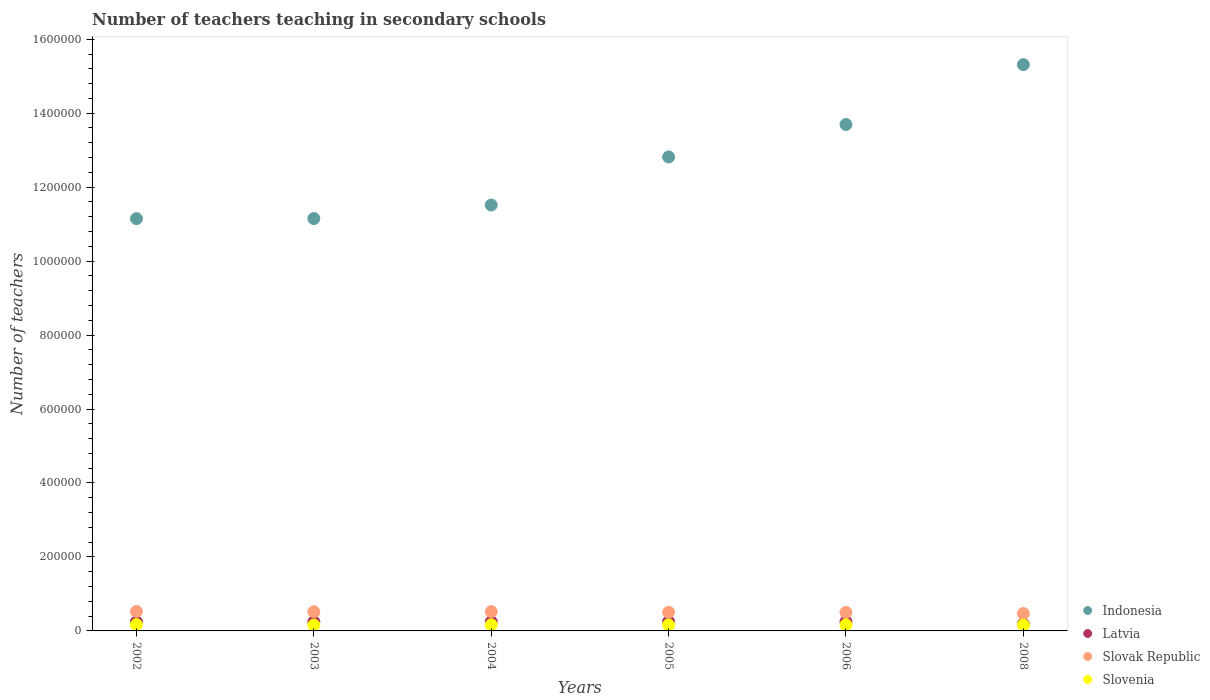How many different coloured dotlines are there?
Make the answer very short. 4. What is the number of teachers teaching in secondary schools in Slovak Republic in 2002?
Ensure brevity in your answer.  5.26e+04. Across all years, what is the maximum number of teachers teaching in secondary schools in Indonesia?
Offer a terse response. 1.53e+06. Across all years, what is the minimum number of teachers teaching in secondary schools in Slovak Republic?
Offer a very short reply. 4.70e+04. In which year was the number of teachers teaching in secondary schools in Slovenia maximum?
Your response must be concise. 2002. In which year was the number of teachers teaching in secondary schools in Slovak Republic minimum?
Provide a succinct answer. 2008. What is the total number of teachers teaching in secondary schools in Slovak Republic in the graph?
Ensure brevity in your answer.  3.04e+05. What is the difference between the number of teachers teaching in secondary schools in Indonesia in 2004 and that in 2005?
Offer a terse response. -1.30e+05. What is the difference between the number of teachers teaching in secondary schools in Indonesia in 2004 and the number of teachers teaching in secondary schools in Slovak Republic in 2003?
Offer a terse response. 1.10e+06. What is the average number of teachers teaching in secondary schools in Slovenia per year?
Offer a terse response. 1.63e+04. In the year 2008, what is the difference between the number of teachers teaching in secondary schools in Slovenia and number of teachers teaching in secondary schools in Indonesia?
Ensure brevity in your answer.  -1.52e+06. What is the ratio of the number of teachers teaching in secondary schools in Slovak Republic in 2005 to that in 2006?
Make the answer very short. 1.01. Is the number of teachers teaching in secondary schools in Slovenia in 2002 less than that in 2006?
Your response must be concise. No. Is the difference between the number of teachers teaching in secondary schools in Slovenia in 2002 and 2004 greater than the difference between the number of teachers teaching in secondary schools in Indonesia in 2002 and 2004?
Your answer should be very brief. Yes. What is the difference between the highest and the second highest number of teachers teaching in secondary schools in Indonesia?
Your answer should be compact. 1.62e+05. What is the difference between the highest and the lowest number of teachers teaching in secondary schools in Slovak Republic?
Offer a very short reply. 5637. In how many years, is the number of teachers teaching in secondary schools in Indonesia greater than the average number of teachers teaching in secondary schools in Indonesia taken over all years?
Keep it short and to the point. 3. Is the sum of the number of teachers teaching in secondary schools in Indonesia in 2005 and 2008 greater than the maximum number of teachers teaching in secondary schools in Slovenia across all years?
Your response must be concise. Yes. Is it the case that in every year, the sum of the number of teachers teaching in secondary schools in Indonesia and number of teachers teaching in secondary schools in Slovak Republic  is greater than the sum of number of teachers teaching in secondary schools in Latvia and number of teachers teaching in secondary schools in Slovenia?
Make the answer very short. No. Is the number of teachers teaching in secondary schools in Slovenia strictly less than the number of teachers teaching in secondary schools in Slovak Republic over the years?
Your answer should be very brief. Yes. How many dotlines are there?
Your answer should be compact. 4. Are the values on the major ticks of Y-axis written in scientific E-notation?
Ensure brevity in your answer.  No. How many legend labels are there?
Your answer should be very brief. 4. What is the title of the graph?
Your response must be concise. Number of teachers teaching in secondary schools. Does "Monaco" appear as one of the legend labels in the graph?
Offer a very short reply. No. What is the label or title of the Y-axis?
Provide a succinct answer. Number of teachers. What is the Number of teachers of Indonesia in 2002?
Keep it short and to the point. 1.11e+06. What is the Number of teachers in Latvia in 2002?
Make the answer very short. 2.45e+04. What is the Number of teachers in Slovak Republic in 2002?
Make the answer very short. 5.26e+04. What is the Number of teachers in Slovenia in 2002?
Your answer should be compact. 1.69e+04. What is the Number of teachers of Indonesia in 2003?
Your answer should be compact. 1.12e+06. What is the Number of teachers of Latvia in 2003?
Make the answer very short. 2.48e+04. What is the Number of teachers in Slovak Republic in 2003?
Ensure brevity in your answer.  5.18e+04. What is the Number of teachers of Slovenia in 2003?
Provide a short and direct response. 1.58e+04. What is the Number of teachers in Indonesia in 2004?
Offer a very short reply. 1.15e+06. What is the Number of teachers of Latvia in 2004?
Provide a short and direct response. 2.50e+04. What is the Number of teachers in Slovak Republic in 2004?
Your answer should be very brief. 5.22e+04. What is the Number of teachers of Slovenia in 2004?
Provide a succinct answer. 1.65e+04. What is the Number of teachers in Indonesia in 2005?
Ensure brevity in your answer.  1.28e+06. What is the Number of teachers in Latvia in 2005?
Make the answer very short. 2.51e+04. What is the Number of teachers in Slovak Republic in 2005?
Give a very brief answer. 5.05e+04. What is the Number of teachers in Slovenia in 2005?
Provide a short and direct response. 1.62e+04. What is the Number of teachers in Indonesia in 2006?
Make the answer very short. 1.37e+06. What is the Number of teachers in Latvia in 2006?
Offer a terse response. 2.52e+04. What is the Number of teachers in Slovak Republic in 2006?
Keep it short and to the point. 4.99e+04. What is the Number of teachers in Slovenia in 2006?
Offer a terse response. 1.64e+04. What is the Number of teachers of Indonesia in 2008?
Your answer should be compact. 1.53e+06. What is the Number of teachers of Latvia in 2008?
Offer a very short reply. 1.86e+04. What is the Number of teachers of Slovak Republic in 2008?
Give a very brief answer. 4.70e+04. What is the Number of teachers of Slovenia in 2008?
Provide a succinct answer. 1.58e+04. Across all years, what is the maximum Number of teachers in Indonesia?
Your answer should be compact. 1.53e+06. Across all years, what is the maximum Number of teachers of Latvia?
Give a very brief answer. 2.52e+04. Across all years, what is the maximum Number of teachers in Slovak Republic?
Offer a very short reply. 5.26e+04. Across all years, what is the maximum Number of teachers of Slovenia?
Offer a very short reply. 1.69e+04. Across all years, what is the minimum Number of teachers in Indonesia?
Your response must be concise. 1.11e+06. Across all years, what is the minimum Number of teachers in Latvia?
Offer a very short reply. 1.86e+04. Across all years, what is the minimum Number of teachers in Slovak Republic?
Provide a short and direct response. 4.70e+04. Across all years, what is the minimum Number of teachers of Slovenia?
Give a very brief answer. 1.58e+04. What is the total Number of teachers in Indonesia in the graph?
Ensure brevity in your answer.  7.56e+06. What is the total Number of teachers in Latvia in the graph?
Offer a very short reply. 1.43e+05. What is the total Number of teachers of Slovak Republic in the graph?
Ensure brevity in your answer.  3.04e+05. What is the total Number of teachers of Slovenia in the graph?
Your answer should be very brief. 9.76e+04. What is the difference between the Number of teachers in Indonesia in 2002 and that in 2003?
Your answer should be very brief. -300. What is the difference between the Number of teachers of Latvia in 2002 and that in 2003?
Provide a short and direct response. -275. What is the difference between the Number of teachers of Slovak Republic in 2002 and that in 2003?
Your answer should be very brief. 809. What is the difference between the Number of teachers of Slovenia in 2002 and that in 2003?
Offer a very short reply. 1104. What is the difference between the Number of teachers of Indonesia in 2002 and that in 2004?
Offer a very short reply. -3.68e+04. What is the difference between the Number of teachers of Latvia in 2002 and that in 2004?
Provide a short and direct response. -497. What is the difference between the Number of teachers in Slovak Republic in 2002 and that in 2004?
Offer a terse response. 434. What is the difference between the Number of teachers in Slovenia in 2002 and that in 2004?
Your response must be concise. 493. What is the difference between the Number of teachers of Indonesia in 2002 and that in 2005?
Make the answer very short. -1.67e+05. What is the difference between the Number of teachers of Latvia in 2002 and that in 2005?
Make the answer very short. -632. What is the difference between the Number of teachers in Slovak Republic in 2002 and that in 2005?
Keep it short and to the point. 2100. What is the difference between the Number of teachers of Slovenia in 2002 and that in 2005?
Offer a terse response. 776. What is the difference between the Number of teachers in Indonesia in 2002 and that in 2006?
Your response must be concise. -2.55e+05. What is the difference between the Number of teachers in Latvia in 2002 and that in 2006?
Your answer should be very brief. -710. What is the difference between the Number of teachers of Slovak Republic in 2002 and that in 2006?
Provide a short and direct response. 2730. What is the difference between the Number of teachers in Slovenia in 2002 and that in 2006?
Your answer should be compact. 544. What is the difference between the Number of teachers in Indonesia in 2002 and that in 2008?
Make the answer very short. -4.17e+05. What is the difference between the Number of teachers of Latvia in 2002 and that in 2008?
Your answer should be compact. 5917. What is the difference between the Number of teachers of Slovak Republic in 2002 and that in 2008?
Give a very brief answer. 5637. What is the difference between the Number of teachers in Slovenia in 2002 and that in 2008?
Offer a terse response. 1159. What is the difference between the Number of teachers of Indonesia in 2003 and that in 2004?
Keep it short and to the point. -3.65e+04. What is the difference between the Number of teachers in Latvia in 2003 and that in 2004?
Give a very brief answer. -222. What is the difference between the Number of teachers in Slovak Republic in 2003 and that in 2004?
Your answer should be compact. -375. What is the difference between the Number of teachers in Slovenia in 2003 and that in 2004?
Make the answer very short. -611. What is the difference between the Number of teachers in Indonesia in 2003 and that in 2005?
Your answer should be compact. -1.67e+05. What is the difference between the Number of teachers of Latvia in 2003 and that in 2005?
Your response must be concise. -357. What is the difference between the Number of teachers in Slovak Republic in 2003 and that in 2005?
Make the answer very short. 1291. What is the difference between the Number of teachers in Slovenia in 2003 and that in 2005?
Ensure brevity in your answer.  -328. What is the difference between the Number of teachers of Indonesia in 2003 and that in 2006?
Your response must be concise. -2.54e+05. What is the difference between the Number of teachers of Latvia in 2003 and that in 2006?
Your answer should be very brief. -435. What is the difference between the Number of teachers in Slovak Republic in 2003 and that in 2006?
Offer a terse response. 1921. What is the difference between the Number of teachers in Slovenia in 2003 and that in 2006?
Give a very brief answer. -560. What is the difference between the Number of teachers of Indonesia in 2003 and that in 2008?
Provide a short and direct response. -4.16e+05. What is the difference between the Number of teachers of Latvia in 2003 and that in 2008?
Make the answer very short. 6192. What is the difference between the Number of teachers in Slovak Republic in 2003 and that in 2008?
Provide a succinct answer. 4828. What is the difference between the Number of teachers in Indonesia in 2004 and that in 2005?
Your answer should be compact. -1.30e+05. What is the difference between the Number of teachers in Latvia in 2004 and that in 2005?
Make the answer very short. -135. What is the difference between the Number of teachers in Slovak Republic in 2004 and that in 2005?
Ensure brevity in your answer.  1666. What is the difference between the Number of teachers in Slovenia in 2004 and that in 2005?
Provide a short and direct response. 283. What is the difference between the Number of teachers in Indonesia in 2004 and that in 2006?
Ensure brevity in your answer.  -2.18e+05. What is the difference between the Number of teachers in Latvia in 2004 and that in 2006?
Your answer should be compact. -213. What is the difference between the Number of teachers of Slovak Republic in 2004 and that in 2006?
Your answer should be very brief. 2296. What is the difference between the Number of teachers in Slovenia in 2004 and that in 2006?
Provide a succinct answer. 51. What is the difference between the Number of teachers of Indonesia in 2004 and that in 2008?
Make the answer very short. -3.80e+05. What is the difference between the Number of teachers in Latvia in 2004 and that in 2008?
Your answer should be compact. 6414. What is the difference between the Number of teachers in Slovak Republic in 2004 and that in 2008?
Your response must be concise. 5203. What is the difference between the Number of teachers in Slovenia in 2004 and that in 2008?
Your answer should be compact. 666. What is the difference between the Number of teachers in Indonesia in 2005 and that in 2006?
Give a very brief answer. -8.77e+04. What is the difference between the Number of teachers of Latvia in 2005 and that in 2006?
Provide a succinct answer. -78. What is the difference between the Number of teachers of Slovak Republic in 2005 and that in 2006?
Your response must be concise. 630. What is the difference between the Number of teachers of Slovenia in 2005 and that in 2006?
Ensure brevity in your answer.  -232. What is the difference between the Number of teachers of Indonesia in 2005 and that in 2008?
Provide a short and direct response. -2.50e+05. What is the difference between the Number of teachers in Latvia in 2005 and that in 2008?
Ensure brevity in your answer.  6549. What is the difference between the Number of teachers of Slovak Republic in 2005 and that in 2008?
Keep it short and to the point. 3537. What is the difference between the Number of teachers of Slovenia in 2005 and that in 2008?
Keep it short and to the point. 383. What is the difference between the Number of teachers in Indonesia in 2006 and that in 2008?
Your answer should be very brief. -1.62e+05. What is the difference between the Number of teachers in Latvia in 2006 and that in 2008?
Ensure brevity in your answer.  6627. What is the difference between the Number of teachers in Slovak Republic in 2006 and that in 2008?
Your answer should be very brief. 2907. What is the difference between the Number of teachers of Slovenia in 2006 and that in 2008?
Make the answer very short. 615. What is the difference between the Number of teachers of Indonesia in 2002 and the Number of teachers of Latvia in 2003?
Your response must be concise. 1.09e+06. What is the difference between the Number of teachers of Indonesia in 2002 and the Number of teachers of Slovak Republic in 2003?
Give a very brief answer. 1.06e+06. What is the difference between the Number of teachers in Indonesia in 2002 and the Number of teachers in Slovenia in 2003?
Offer a terse response. 1.10e+06. What is the difference between the Number of teachers in Latvia in 2002 and the Number of teachers in Slovak Republic in 2003?
Provide a short and direct response. -2.73e+04. What is the difference between the Number of teachers in Latvia in 2002 and the Number of teachers in Slovenia in 2003?
Your answer should be compact. 8647. What is the difference between the Number of teachers of Slovak Republic in 2002 and the Number of teachers of Slovenia in 2003?
Make the answer very short. 3.68e+04. What is the difference between the Number of teachers in Indonesia in 2002 and the Number of teachers in Latvia in 2004?
Your answer should be very brief. 1.09e+06. What is the difference between the Number of teachers of Indonesia in 2002 and the Number of teachers of Slovak Republic in 2004?
Give a very brief answer. 1.06e+06. What is the difference between the Number of teachers in Indonesia in 2002 and the Number of teachers in Slovenia in 2004?
Offer a terse response. 1.10e+06. What is the difference between the Number of teachers in Latvia in 2002 and the Number of teachers in Slovak Republic in 2004?
Offer a very short reply. -2.77e+04. What is the difference between the Number of teachers in Latvia in 2002 and the Number of teachers in Slovenia in 2004?
Your response must be concise. 8036. What is the difference between the Number of teachers in Slovak Republic in 2002 and the Number of teachers in Slovenia in 2004?
Offer a very short reply. 3.62e+04. What is the difference between the Number of teachers in Indonesia in 2002 and the Number of teachers in Latvia in 2005?
Provide a succinct answer. 1.09e+06. What is the difference between the Number of teachers in Indonesia in 2002 and the Number of teachers in Slovak Republic in 2005?
Give a very brief answer. 1.06e+06. What is the difference between the Number of teachers of Indonesia in 2002 and the Number of teachers of Slovenia in 2005?
Give a very brief answer. 1.10e+06. What is the difference between the Number of teachers of Latvia in 2002 and the Number of teachers of Slovak Republic in 2005?
Offer a terse response. -2.60e+04. What is the difference between the Number of teachers of Latvia in 2002 and the Number of teachers of Slovenia in 2005?
Your answer should be very brief. 8319. What is the difference between the Number of teachers in Slovak Republic in 2002 and the Number of teachers in Slovenia in 2005?
Ensure brevity in your answer.  3.65e+04. What is the difference between the Number of teachers of Indonesia in 2002 and the Number of teachers of Latvia in 2006?
Give a very brief answer. 1.09e+06. What is the difference between the Number of teachers of Indonesia in 2002 and the Number of teachers of Slovak Republic in 2006?
Give a very brief answer. 1.06e+06. What is the difference between the Number of teachers in Indonesia in 2002 and the Number of teachers in Slovenia in 2006?
Keep it short and to the point. 1.10e+06. What is the difference between the Number of teachers in Latvia in 2002 and the Number of teachers in Slovak Republic in 2006?
Your response must be concise. -2.54e+04. What is the difference between the Number of teachers of Latvia in 2002 and the Number of teachers of Slovenia in 2006?
Give a very brief answer. 8087. What is the difference between the Number of teachers in Slovak Republic in 2002 and the Number of teachers in Slovenia in 2006?
Your answer should be compact. 3.62e+04. What is the difference between the Number of teachers in Indonesia in 2002 and the Number of teachers in Latvia in 2008?
Your answer should be compact. 1.10e+06. What is the difference between the Number of teachers in Indonesia in 2002 and the Number of teachers in Slovak Republic in 2008?
Keep it short and to the point. 1.07e+06. What is the difference between the Number of teachers of Indonesia in 2002 and the Number of teachers of Slovenia in 2008?
Provide a short and direct response. 1.10e+06. What is the difference between the Number of teachers in Latvia in 2002 and the Number of teachers in Slovak Republic in 2008?
Offer a terse response. -2.25e+04. What is the difference between the Number of teachers in Latvia in 2002 and the Number of teachers in Slovenia in 2008?
Keep it short and to the point. 8702. What is the difference between the Number of teachers in Slovak Republic in 2002 and the Number of teachers in Slovenia in 2008?
Provide a short and direct response. 3.68e+04. What is the difference between the Number of teachers in Indonesia in 2003 and the Number of teachers in Latvia in 2004?
Your answer should be compact. 1.09e+06. What is the difference between the Number of teachers of Indonesia in 2003 and the Number of teachers of Slovak Republic in 2004?
Offer a very short reply. 1.06e+06. What is the difference between the Number of teachers in Indonesia in 2003 and the Number of teachers in Slovenia in 2004?
Your response must be concise. 1.10e+06. What is the difference between the Number of teachers of Latvia in 2003 and the Number of teachers of Slovak Republic in 2004?
Offer a terse response. -2.74e+04. What is the difference between the Number of teachers of Latvia in 2003 and the Number of teachers of Slovenia in 2004?
Give a very brief answer. 8311. What is the difference between the Number of teachers of Slovak Republic in 2003 and the Number of teachers of Slovenia in 2004?
Provide a succinct answer. 3.54e+04. What is the difference between the Number of teachers in Indonesia in 2003 and the Number of teachers in Latvia in 2005?
Offer a very short reply. 1.09e+06. What is the difference between the Number of teachers of Indonesia in 2003 and the Number of teachers of Slovak Republic in 2005?
Give a very brief answer. 1.06e+06. What is the difference between the Number of teachers in Indonesia in 2003 and the Number of teachers in Slovenia in 2005?
Your answer should be compact. 1.10e+06. What is the difference between the Number of teachers in Latvia in 2003 and the Number of teachers in Slovak Republic in 2005?
Keep it short and to the point. -2.58e+04. What is the difference between the Number of teachers of Latvia in 2003 and the Number of teachers of Slovenia in 2005?
Offer a very short reply. 8594. What is the difference between the Number of teachers in Slovak Republic in 2003 and the Number of teachers in Slovenia in 2005?
Ensure brevity in your answer.  3.56e+04. What is the difference between the Number of teachers in Indonesia in 2003 and the Number of teachers in Latvia in 2006?
Ensure brevity in your answer.  1.09e+06. What is the difference between the Number of teachers of Indonesia in 2003 and the Number of teachers of Slovak Republic in 2006?
Provide a short and direct response. 1.07e+06. What is the difference between the Number of teachers of Indonesia in 2003 and the Number of teachers of Slovenia in 2006?
Your answer should be very brief. 1.10e+06. What is the difference between the Number of teachers of Latvia in 2003 and the Number of teachers of Slovak Republic in 2006?
Make the answer very short. -2.51e+04. What is the difference between the Number of teachers of Latvia in 2003 and the Number of teachers of Slovenia in 2006?
Your answer should be compact. 8362. What is the difference between the Number of teachers in Slovak Republic in 2003 and the Number of teachers in Slovenia in 2006?
Your answer should be very brief. 3.54e+04. What is the difference between the Number of teachers in Indonesia in 2003 and the Number of teachers in Latvia in 2008?
Keep it short and to the point. 1.10e+06. What is the difference between the Number of teachers in Indonesia in 2003 and the Number of teachers in Slovak Republic in 2008?
Your answer should be compact. 1.07e+06. What is the difference between the Number of teachers in Indonesia in 2003 and the Number of teachers in Slovenia in 2008?
Your answer should be very brief. 1.10e+06. What is the difference between the Number of teachers of Latvia in 2003 and the Number of teachers of Slovak Republic in 2008?
Offer a very short reply. -2.22e+04. What is the difference between the Number of teachers in Latvia in 2003 and the Number of teachers in Slovenia in 2008?
Offer a very short reply. 8977. What is the difference between the Number of teachers of Slovak Republic in 2003 and the Number of teachers of Slovenia in 2008?
Give a very brief answer. 3.60e+04. What is the difference between the Number of teachers in Indonesia in 2004 and the Number of teachers in Latvia in 2005?
Your response must be concise. 1.13e+06. What is the difference between the Number of teachers of Indonesia in 2004 and the Number of teachers of Slovak Republic in 2005?
Offer a very short reply. 1.10e+06. What is the difference between the Number of teachers in Indonesia in 2004 and the Number of teachers in Slovenia in 2005?
Keep it short and to the point. 1.14e+06. What is the difference between the Number of teachers of Latvia in 2004 and the Number of teachers of Slovak Republic in 2005?
Your answer should be compact. -2.55e+04. What is the difference between the Number of teachers in Latvia in 2004 and the Number of teachers in Slovenia in 2005?
Keep it short and to the point. 8816. What is the difference between the Number of teachers in Slovak Republic in 2004 and the Number of teachers in Slovenia in 2005?
Ensure brevity in your answer.  3.60e+04. What is the difference between the Number of teachers of Indonesia in 2004 and the Number of teachers of Latvia in 2006?
Keep it short and to the point. 1.13e+06. What is the difference between the Number of teachers of Indonesia in 2004 and the Number of teachers of Slovak Republic in 2006?
Offer a terse response. 1.10e+06. What is the difference between the Number of teachers in Indonesia in 2004 and the Number of teachers in Slovenia in 2006?
Offer a very short reply. 1.14e+06. What is the difference between the Number of teachers of Latvia in 2004 and the Number of teachers of Slovak Republic in 2006?
Ensure brevity in your answer.  -2.49e+04. What is the difference between the Number of teachers in Latvia in 2004 and the Number of teachers in Slovenia in 2006?
Offer a terse response. 8584. What is the difference between the Number of teachers of Slovak Republic in 2004 and the Number of teachers of Slovenia in 2006?
Give a very brief answer. 3.58e+04. What is the difference between the Number of teachers in Indonesia in 2004 and the Number of teachers in Latvia in 2008?
Offer a terse response. 1.13e+06. What is the difference between the Number of teachers in Indonesia in 2004 and the Number of teachers in Slovak Republic in 2008?
Your answer should be very brief. 1.10e+06. What is the difference between the Number of teachers of Indonesia in 2004 and the Number of teachers of Slovenia in 2008?
Keep it short and to the point. 1.14e+06. What is the difference between the Number of teachers of Latvia in 2004 and the Number of teachers of Slovak Republic in 2008?
Provide a succinct answer. -2.20e+04. What is the difference between the Number of teachers in Latvia in 2004 and the Number of teachers in Slovenia in 2008?
Provide a short and direct response. 9199. What is the difference between the Number of teachers of Slovak Republic in 2004 and the Number of teachers of Slovenia in 2008?
Your response must be concise. 3.64e+04. What is the difference between the Number of teachers in Indonesia in 2005 and the Number of teachers in Latvia in 2006?
Ensure brevity in your answer.  1.26e+06. What is the difference between the Number of teachers in Indonesia in 2005 and the Number of teachers in Slovak Republic in 2006?
Provide a short and direct response. 1.23e+06. What is the difference between the Number of teachers of Indonesia in 2005 and the Number of teachers of Slovenia in 2006?
Your answer should be compact. 1.27e+06. What is the difference between the Number of teachers in Latvia in 2005 and the Number of teachers in Slovak Republic in 2006?
Your response must be concise. -2.48e+04. What is the difference between the Number of teachers of Latvia in 2005 and the Number of teachers of Slovenia in 2006?
Your response must be concise. 8719. What is the difference between the Number of teachers in Slovak Republic in 2005 and the Number of teachers in Slovenia in 2006?
Provide a short and direct response. 3.41e+04. What is the difference between the Number of teachers in Indonesia in 2005 and the Number of teachers in Latvia in 2008?
Provide a short and direct response. 1.26e+06. What is the difference between the Number of teachers of Indonesia in 2005 and the Number of teachers of Slovak Republic in 2008?
Keep it short and to the point. 1.23e+06. What is the difference between the Number of teachers in Indonesia in 2005 and the Number of teachers in Slovenia in 2008?
Your response must be concise. 1.27e+06. What is the difference between the Number of teachers in Latvia in 2005 and the Number of teachers in Slovak Republic in 2008?
Your answer should be very brief. -2.19e+04. What is the difference between the Number of teachers of Latvia in 2005 and the Number of teachers of Slovenia in 2008?
Your response must be concise. 9334. What is the difference between the Number of teachers in Slovak Republic in 2005 and the Number of teachers in Slovenia in 2008?
Offer a terse response. 3.47e+04. What is the difference between the Number of teachers in Indonesia in 2006 and the Number of teachers in Latvia in 2008?
Make the answer very short. 1.35e+06. What is the difference between the Number of teachers of Indonesia in 2006 and the Number of teachers of Slovak Republic in 2008?
Provide a succinct answer. 1.32e+06. What is the difference between the Number of teachers in Indonesia in 2006 and the Number of teachers in Slovenia in 2008?
Make the answer very short. 1.35e+06. What is the difference between the Number of teachers of Latvia in 2006 and the Number of teachers of Slovak Republic in 2008?
Your answer should be compact. -2.18e+04. What is the difference between the Number of teachers in Latvia in 2006 and the Number of teachers in Slovenia in 2008?
Your answer should be compact. 9412. What is the difference between the Number of teachers of Slovak Republic in 2006 and the Number of teachers of Slovenia in 2008?
Provide a succinct answer. 3.41e+04. What is the average Number of teachers in Indonesia per year?
Offer a very short reply. 1.26e+06. What is the average Number of teachers in Latvia per year?
Offer a terse response. 2.39e+04. What is the average Number of teachers in Slovak Republic per year?
Give a very brief answer. 5.07e+04. What is the average Number of teachers in Slovenia per year?
Give a very brief answer. 1.63e+04. In the year 2002, what is the difference between the Number of teachers of Indonesia and Number of teachers of Latvia?
Ensure brevity in your answer.  1.09e+06. In the year 2002, what is the difference between the Number of teachers of Indonesia and Number of teachers of Slovak Republic?
Keep it short and to the point. 1.06e+06. In the year 2002, what is the difference between the Number of teachers in Indonesia and Number of teachers in Slovenia?
Your response must be concise. 1.10e+06. In the year 2002, what is the difference between the Number of teachers in Latvia and Number of teachers in Slovak Republic?
Your answer should be very brief. -2.81e+04. In the year 2002, what is the difference between the Number of teachers in Latvia and Number of teachers in Slovenia?
Make the answer very short. 7543. In the year 2002, what is the difference between the Number of teachers in Slovak Republic and Number of teachers in Slovenia?
Ensure brevity in your answer.  3.57e+04. In the year 2003, what is the difference between the Number of teachers in Indonesia and Number of teachers in Latvia?
Provide a succinct answer. 1.09e+06. In the year 2003, what is the difference between the Number of teachers in Indonesia and Number of teachers in Slovak Republic?
Keep it short and to the point. 1.06e+06. In the year 2003, what is the difference between the Number of teachers in Indonesia and Number of teachers in Slovenia?
Ensure brevity in your answer.  1.10e+06. In the year 2003, what is the difference between the Number of teachers in Latvia and Number of teachers in Slovak Republic?
Offer a very short reply. -2.70e+04. In the year 2003, what is the difference between the Number of teachers of Latvia and Number of teachers of Slovenia?
Your answer should be compact. 8922. In the year 2003, what is the difference between the Number of teachers in Slovak Republic and Number of teachers in Slovenia?
Make the answer very short. 3.60e+04. In the year 2004, what is the difference between the Number of teachers of Indonesia and Number of teachers of Latvia?
Your response must be concise. 1.13e+06. In the year 2004, what is the difference between the Number of teachers of Indonesia and Number of teachers of Slovak Republic?
Offer a terse response. 1.10e+06. In the year 2004, what is the difference between the Number of teachers of Indonesia and Number of teachers of Slovenia?
Provide a succinct answer. 1.14e+06. In the year 2004, what is the difference between the Number of teachers in Latvia and Number of teachers in Slovak Republic?
Keep it short and to the point. -2.72e+04. In the year 2004, what is the difference between the Number of teachers of Latvia and Number of teachers of Slovenia?
Keep it short and to the point. 8533. In the year 2004, what is the difference between the Number of teachers in Slovak Republic and Number of teachers in Slovenia?
Provide a succinct answer. 3.57e+04. In the year 2005, what is the difference between the Number of teachers in Indonesia and Number of teachers in Latvia?
Provide a short and direct response. 1.26e+06. In the year 2005, what is the difference between the Number of teachers in Indonesia and Number of teachers in Slovak Republic?
Your response must be concise. 1.23e+06. In the year 2005, what is the difference between the Number of teachers in Indonesia and Number of teachers in Slovenia?
Provide a short and direct response. 1.27e+06. In the year 2005, what is the difference between the Number of teachers of Latvia and Number of teachers of Slovak Republic?
Keep it short and to the point. -2.54e+04. In the year 2005, what is the difference between the Number of teachers of Latvia and Number of teachers of Slovenia?
Offer a very short reply. 8951. In the year 2005, what is the difference between the Number of teachers of Slovak Republic and Number of teachers of Slovenia?
Offer a terse response. 3.44e+04. In the year 2006, what is the difference between the Number of teachers of Indonesia and Number of teachers of Latvia?
Make the answer very short. 1.34e+06. In the year 2006, what is the difference between the Number of teachers in Indonesia and Number of teachers in Slovak Republic?
Keep it short and to the point. 1.32e+06. In the year 2006, what is the difference between the Number of teachers of Indonesia and Number of teachers of Slovenia?
Keep it short and to the point. 1.35e+06. In the year 2006, what is the difference between the Number of teachers in Latvia and Number of teachers in Slovak Republic?
Your answer should be compact. -2.47e+04. In the year 2006, what is the difference between the Number of teachers in Latvia and Number of teachers in Slovenia?
Your answer should be very brief. 8797. In the year 2006, what is the difference between the Number of teachers of Slovak Republic and Number of teachers of Slovenia?
Provide a short and direct response. 3.35e+04. In the year 2008, what is the difference between the Number of teachers of Indonesia and Number of teachers of Latvia?
Provide a short and direct response. 1.51e+06. In the year 2008, what is the difference between the Number of teachers of Indonesia and Number of teachers of Slovak Republic?
Keep it short and to the point. 1.48e+06. In the year 2008, what is the difference between the Number of teachers of Indonesia and Number of teachers of Slovenia?
Your answer should be compact. 1.52e+06. In the year 2008, what is the difference between the Number of teachers in Latvia and Number of teachers in Slovak Republic?
Keep it short and to the point. -2.84e+04. In the year 2008, what is the difference between the Number of teachers in Latvia and Number of teachers in Slovenia?
Keep it short and to the point. 2785. In the year 2008, what is the difference between the Number of teachers in Slovak Republic and Number of teachers in Slovenia?
Offer a terse response. 3.12e+04. What is the ratio of the Number of teachers of Indonesia in 2002 to that in 2003?
Keep it short and to the point. 1. What is the ratio of the Number of teachers of Latvia in 2002 to that in 2003?
Make the answer very short. 0.99. What is the ratio of the Number of teachers of Slovak Republic in 2002 to that in 2003?
Offer a terse response. 1.02. What is the ratio of the Number of teachers of Slovenia in 2002 to that in 2003?
Provide a short and direct response. 1.07. What is the ratio of the Number of teachers of Indonesia in 2002 to that in 2004?
Your answer should be very brief. 0.97. What is the ratio of the Number of teachers of Latvia in 2002 to that in 2004?
Offer a very short reply. 0.98. What is the ratio of the Number of teachers in Slovak Republic in 2002 to that in 2004?
Keep it short and to the point. 1.01. What is the ratio of the Number of teachers in Slovenia in 2002 to that in 2004?
Ensure brevity in your answer.  1.03. What is the ratio of the Number of teachers of Indonesia in 2002 to that in 2005?
Offer a very short reply. 0.87. What is the ratio of the Number of teachers in Latvia in 2002 to that in 2005?
Keep it short and to the point. 0.97. What is the ratio of the Number of teachers in Slovak Republic in 2002 to that in 2005?
Offer a terse response. 1.04. What is the ratio of the Number of teachers in Slovenia in 2002 to that in 2005?
Ensure brevity in your answer.  1.05. What is the ratio of the Number of teachers of Indonesia in 2002 to that in 2006?
Offer a terse response. 0.81. What is the ratio of the Number of teachers of Latvia in 2002 to that in 2006?
Keep it short and to the point. 0.97. What is the ratio of the Number of teachers in Slovak Republic in 2002 to that in 2006?
Your answer should be compact. 1.05. What is the ratio of the Number of teachers in Slovenia in 2002 to that in 2006?
Provide a succinct answer. 1.03. What is the ratio of the Number of teachers in Indonesia in 2002 to that in 2008?
Your answer should be very brief. 0.73. What is the ratio of the Number of teachers of Latvia in 2002 to that in 2008?
Provide a short and direct response. 1.32. What is the ratio of the Number of teachers in Slovak Republic in 2002 to that in 2008?
Your answer should be very brief. 1.12. What is the ratio of the Number of teachers in Slovenia in 2002 to that in 2008?
Your answer should be compact. 1.07. What is the ratio of the Number of teachers of Indonesia in 2003 to that in 2004?
Keep it short and to the point. 0.97. What is the ratio of the Number of teachers of Slovenia in 2003 to that in 2004?
Ensure brevity in your answer.  0.96. What is the ratio of the Number of teachers in Indonesia in 2003 to that in 2005?
Ensure brevity in your answer.  0.87. What is the ratio of the Number of teachers of Latvia in 2003 to that in 2005?
Keep it short and to the point. 0.99. What is the ratio of the Number of teachers in Slovak Republic in 2003 to that in 2005?
Offer a terse response. 1.03. What is the ratio of the Number of teachers of Slovenia in 2003 to that in 2005?
Your answer should be very brief. 0.98. What is the ratio of the Number of teachers of Indonesia in 2003 to that in 2006?
Your response must be concise. 0.81. What is the ratio of the Number of teachers of Latvia in 2003 to that in 2006?
Ensure brevity in your answer.  0.98. What is the ratio of the Number of teachers of Slovak Republic in 2003 to that in 2006?
Offer a very short reply. 1.04. What is the ratio of the Number of teachers in Slovenia in 2003 to that in 2006?
Provide a succinct answer. 0.97. What is the ratio of the Number of teachers in Indonesia in 2003 to that in 2008?
Your answer should be compact. 0.73. What is the ratio of the Number of teachers of Latvia in 2003 to that in 2008?
Provide a short and direct response. 1.33. What is the ratio of the Number of teachers in Slovak Republic in 2003 to that in 2008?
Your answer should be compact. 1.1. What is the ratio of the Number of teachers of Indonesia in 2004 to that in 2005?
Your answer should be compact. 0.9. What is the ratio of the Number of teachers in Latvia in 2004 to that in 2005?
Your answer should be compact. 0.99. What is the ratio of the Number of teachers in Slovak Republic in 2004 to that in 2005?
Your answer should be compact. 1.03. What is the ratio of the Number of teachers in Slovenia in 2004 to that in 2005?
Give a very brief answer. 1.02. What is the ratio of the Number of teachers in Indonesia in 2004 to that in 2006?
Make the answer very short. 0.84. What is the ratio of the Number of teachers of Latvia in 2004 to that in 2006?
Your answer should be compact. 0.99. What is the ratio of the Number of teachers of Slovak Republic in 2004 to that in 2006?
Offer a terse response. 1.05. What is the ratio of the Number of teachers of Indonesia in 2004 to that in 2008?
Your response must be concise. 0.75. What is the ratio of the Number of teachers of Latvia in 2004 to that in 2008?
Offer a terse response. 1.35. What is the ratio of the Number of teachers in Slovak Republic in 2004 to that in 2008?
Offer a terse response. 1.11. What is the ratio of the Number of teachers of Slovenia in 2004 to that in 2008?
Provide a succinct answer. 1.04. What is the ratio of the Number of teachers of Indonesia in 2005 to that in 2006?
Make the answer very short. 0.94. What is the ratio of the Number of teachers of Slovak Republic in 2005 to that in 2006?
Offer a very short reply. 1.01. What is the ratio of the Number of teachers in Slovenia in 2005 to that in 2006?
Provide a short and direct response. 0.99. What is the ratio of the Number of teachers of Indonesia in 2005 to that in 2008?
Make the answer very short. 0.84. What is the ratio of the Number of teachers of Latvia in 2005 to that in 2008?
Provide a short and direct response. 1.35. What is the ratio of the Number of teachers of Slovak Republic in 2005 to that in 2008?
Offer a terse response. 1.08. What is the ratio of the Number of teachers in Slovenia in 2005 to that in 2008?
Give a very brief answer. 1.02. What is the ratio of the Number of teachers in Indonesia in 2006 to that in 2008?
Keep it short and to the point. 0.89. What is the ratio of the Number of teachers of Latvia in 2006 to that in 2008?
Provide a succinct answer. 1.36. What is the ratio of the Number of teachers of Slovak Republic in 2006 to that in 2008?
Ensure brevity in your answer.  1.06. What is the ratio of the Number of teachers of Slovenia in 2006 to that in 2008?
Your response must be concise. 1.04. What is the difference between the highest and the second highest Number of teachers in Indonesia?
Provide a succinct answer. 1.62e+05. What is the difference between the highest and the second highest Number of teachers in Slovak Republic?
Give a very brief answer. 434. What is the difference between the highest and the second highest Number of teachers in Slovenia?
Your answer should be very brief. 493. What is the difference between the highest and the lowest Number of teachers in Indonesia?
Provide a succinct answer. 4.17e+05. What is the difference between the highest and the lowest Number of teachers of Latvia?
Your answer should be compact. 6627. What is the difference between the highest and the lowest Number of teachers in Slovak Republic?
Keep it short and to the point. 5637. What is the difference between the highest and the lowest Number of teachers in Slovenia?
Your response must be concise. 1159. 